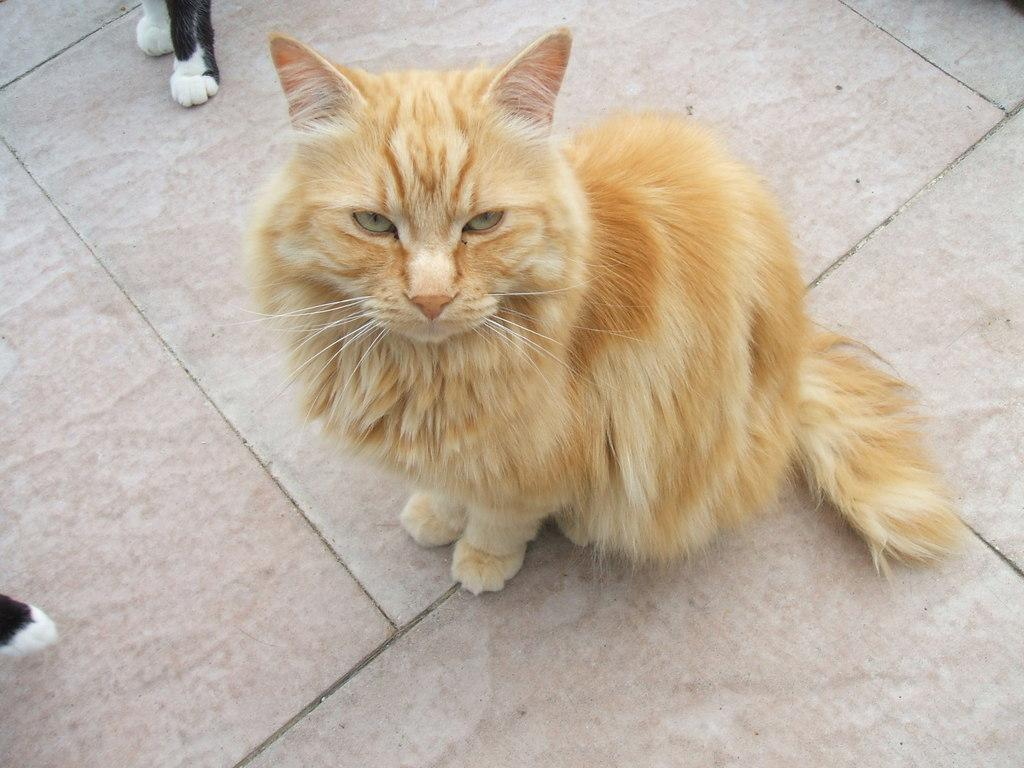What type of animal is in the image? There is a cat in the image. Can you describe the color of the cat? The cat has a white and brown color. Where is the cat located in the image? The cat is sitting on a surface. What type of sea creature is visible in the mouth of the cat in the image? There is no sea creature visible in the mouth of the cat in the image, as the cat does not have a mouth or any sea creatures present. 